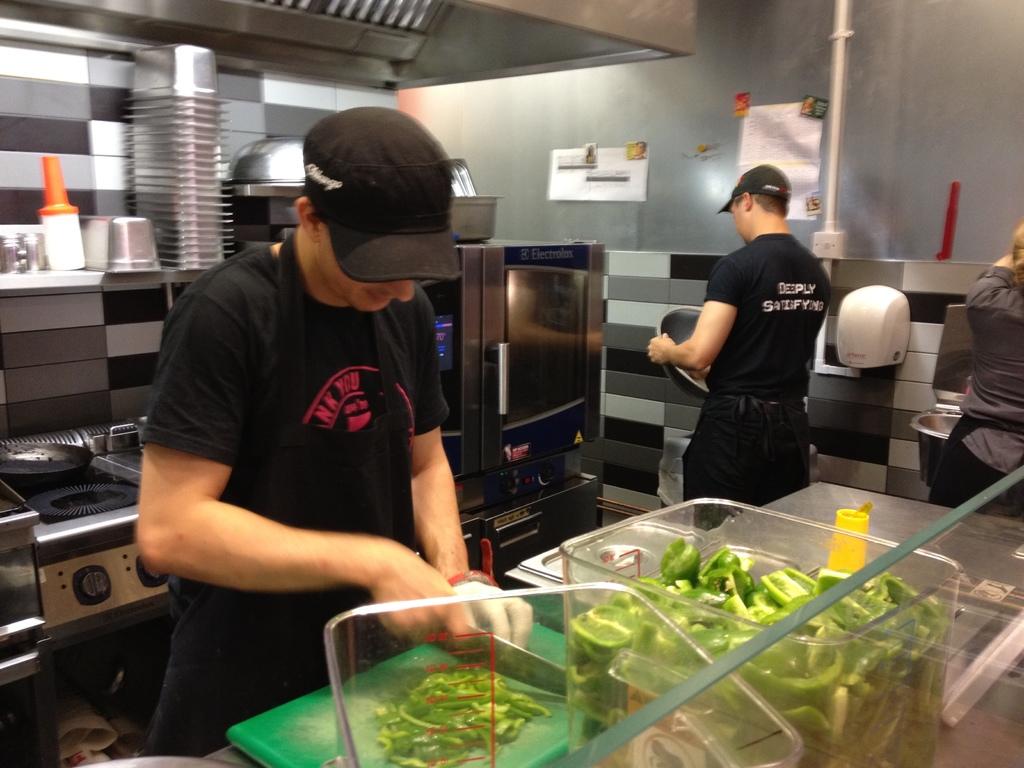What is written on the back of the shirt?
Make the answer very short. Deeply satisfying. 